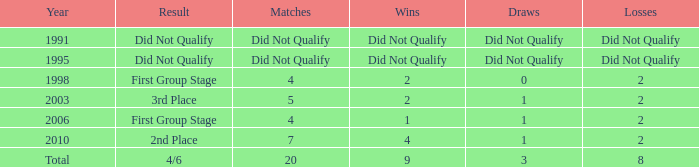What were the games where the teams concluded in the initial group phase, in 1998? 4.0. 